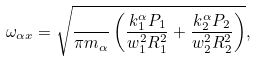<formula> <loc_0><loc_0><loc_500><loc_500>\omega _ { \alpha x } = \sqrt { \frac { } { \pi m _ { \alpha } } \left ( \frac { k ^ { \alpha } _ { 1 } P _ { 1 } } { w _ { 1 } ^ { 2 } R _ { 1 } ^ { 2 } } + \frac { k ^ { \alpha } _ { 2 } P _ { 2 } } { w _ { 2 } ^ { 2 } R _ { 2 } ^ { 2 } } \right ) } ,</formula> 